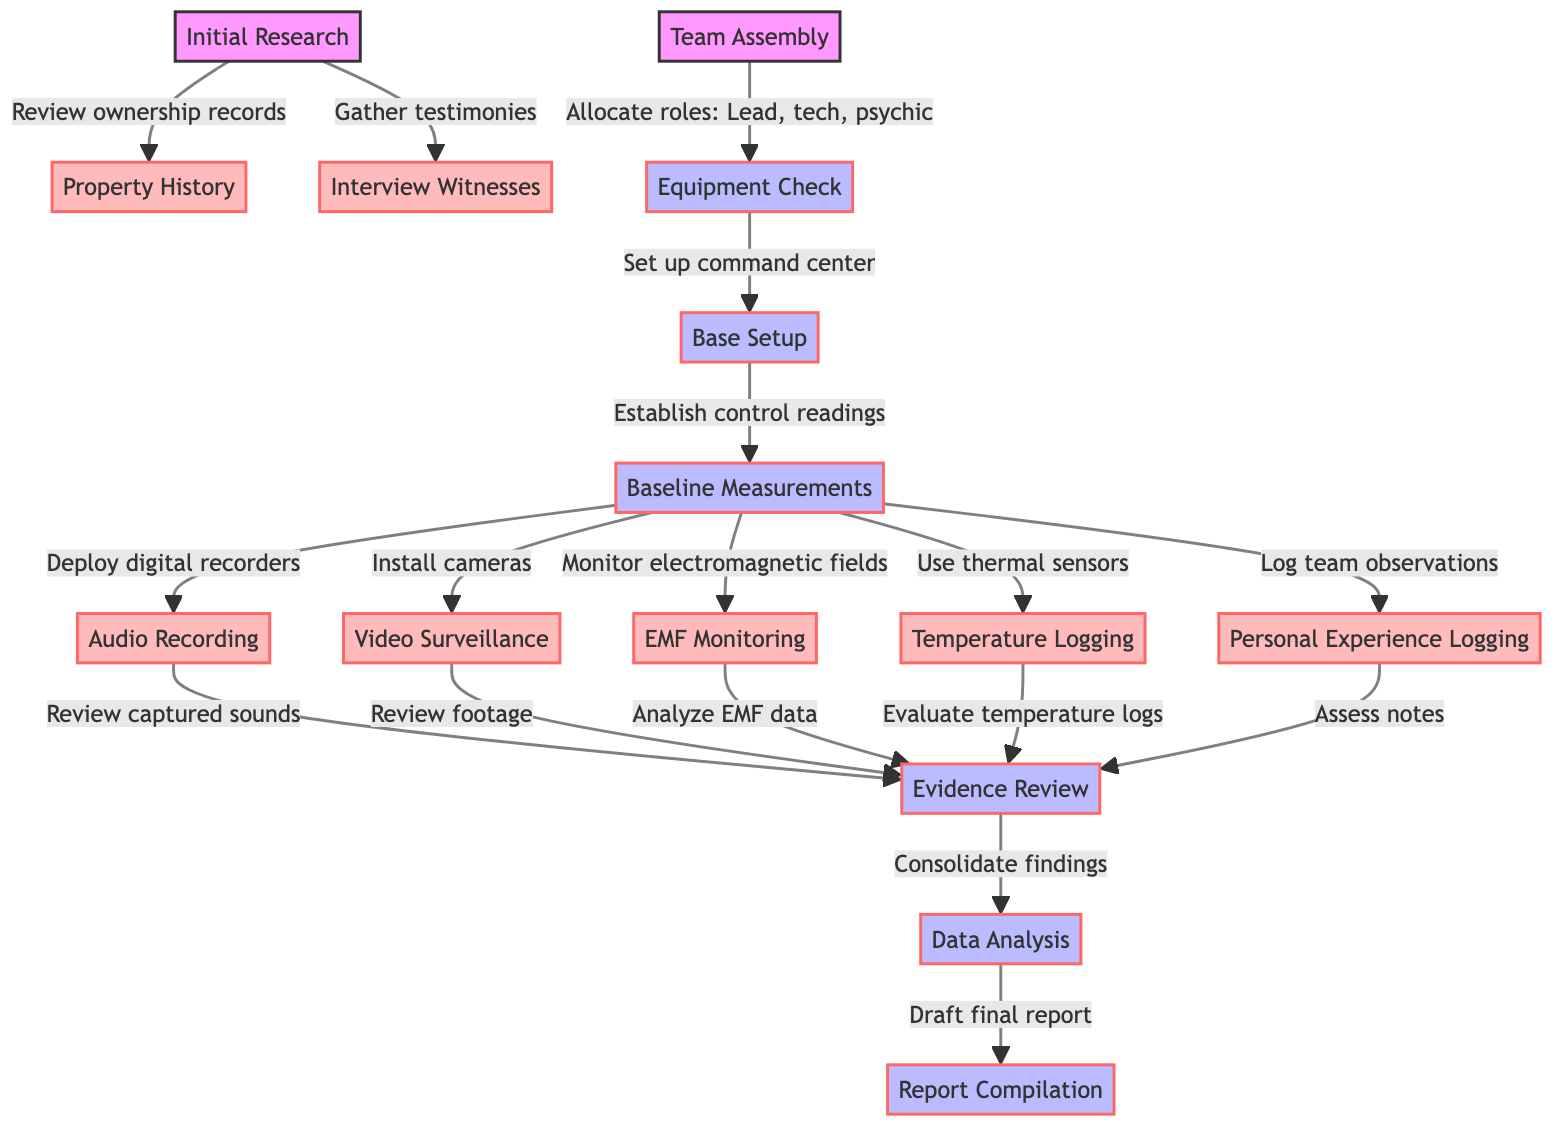What is the first step in a haunted house investigation? According to the diagram, the first step is "Initial Research." This is indicated as the starting point before any other actions are taken.
Answer: Initial Research How many types of equipment are listed in the diagram? The diagram contains six types of equipment: Audio Recording, Video Surveillance, EMF Monitoring, Temperature Logging, and Personal Experience Logging. Counting these gives a total of five types used in the investigation.
Answer: Five What role is allocated during the team assembly phase? The diagram specifically mentions the roles to be allocated as Lead, tech, and psychic during the "Team Assembly" phase.
Answer: Lead, tech, psychic Which step follows after "Baseline Measurements"? The next step after "Baseline Measurements" is "Audio Recording" according to the flow from the baseline process in the diagram.
Answer: Audio Recording How many evidence review types are indicated before data analysis? The diagram shows five types of evidence reviewed before analysis: sounds (Audio Recording), footage (Video Surveillance), EMF data (EMF Monitoring), temperature logs (Temperature Logging), and notes (Personal Experience Logging). Therefore, there are five evidence review types.
Answer: Five What is the outcome of "Consolidate findings"? The outcome of "Consolidate findings" is "Draft final report," which indicates that the findings culminate in a formal report for documentation.
Answer: Draft final report What happens during the "Evidence Review" phase? During the "Evidence Review" phase, reviewed materials include captured sounds from audio recordings, video footage, EMF data, temperature logs, and team notes. Each of these contributes to the consolidation of findings.
Answer: Review captured sounds, Review footage, Analyze EMF data, Evaluate temperature logs, Assess notes What is the main objective of the "Data Analysis" phase? The purpose of the "Data Analysis" phase is to evaluate and interpret the findings collected during the investigation, serving as an essential step towards compiling a final report.
Answer: Evaluate and interpret findings At which step do witnesses get interviewed? Witnesses are interviewed at the "Interview Witnesses" step, which directly follows the "Initial Research" phase based on the flow of the diagram.
Answer: Interview Witnesses 